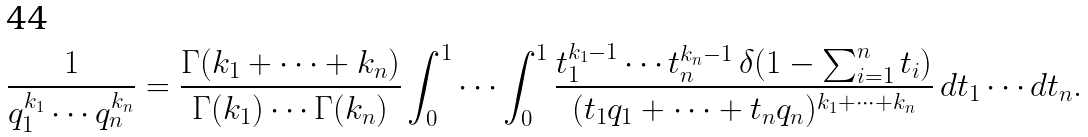<formula> <loc_0><loc_0><loc_500><loc_500>\frac { 1 } { q _ { 1 } ^ { k _ { 1 } } \cdots q _ { n } ^ { k _ { n } } } = \frac { \Gamma ( k _ { 1 } + \cdots + k _ { n } ) } { \Gamma ( k _ { 1 } ) \cdots \Gamma ( k _ { n } ) } \int _ { 0 } ^ { 1 } \cdots \int _ { 0 } ^ { 1 } \frac { t _ { 1 } ^ { k _ { 1 } - 1 } \cdots t _ { n } ^ { k _ { n } - 1 } \, \delta ( 1 - \sum _ { i = 1 } ^ { n } t _ { i } ) } { ( t _ { 1 } q _ { 1 } + \cdots + t _ { n } q _ { n } ) ^ { k _ { 1 } + \cdots + k _ { n } } } \, d t _ { 1 } \cdots d t _ { n } .</formula> 